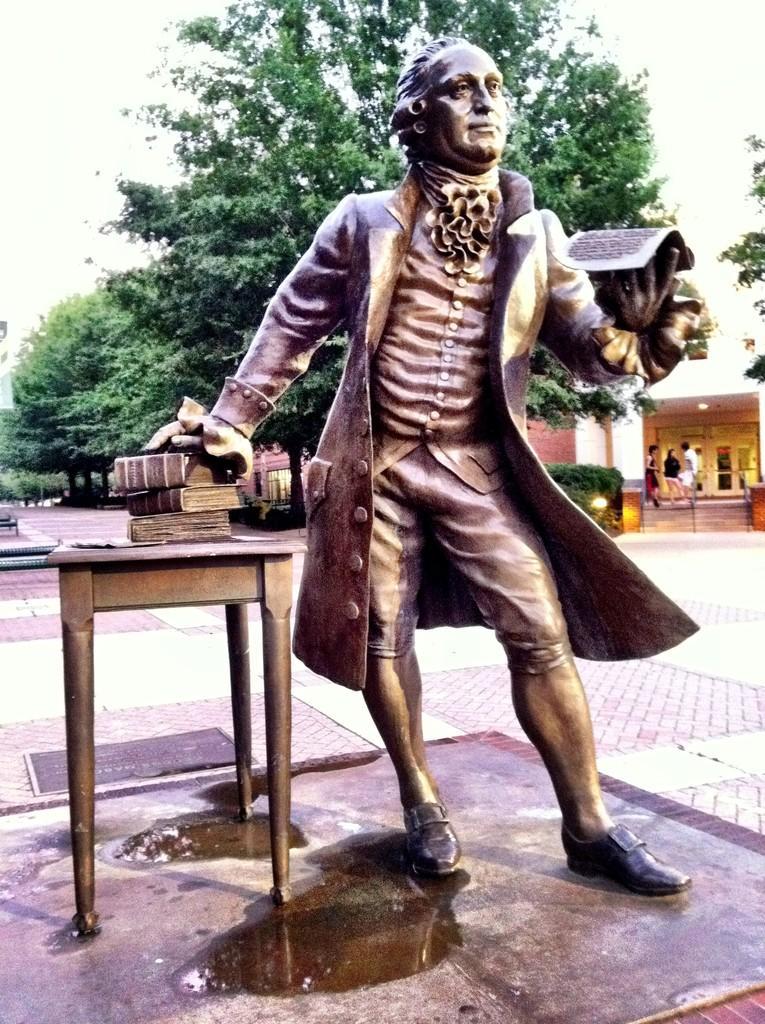Please provide a concise description of this image. This picture shows a statue of a man standing and a table and books on it and we see a tree back of the statue and a House 